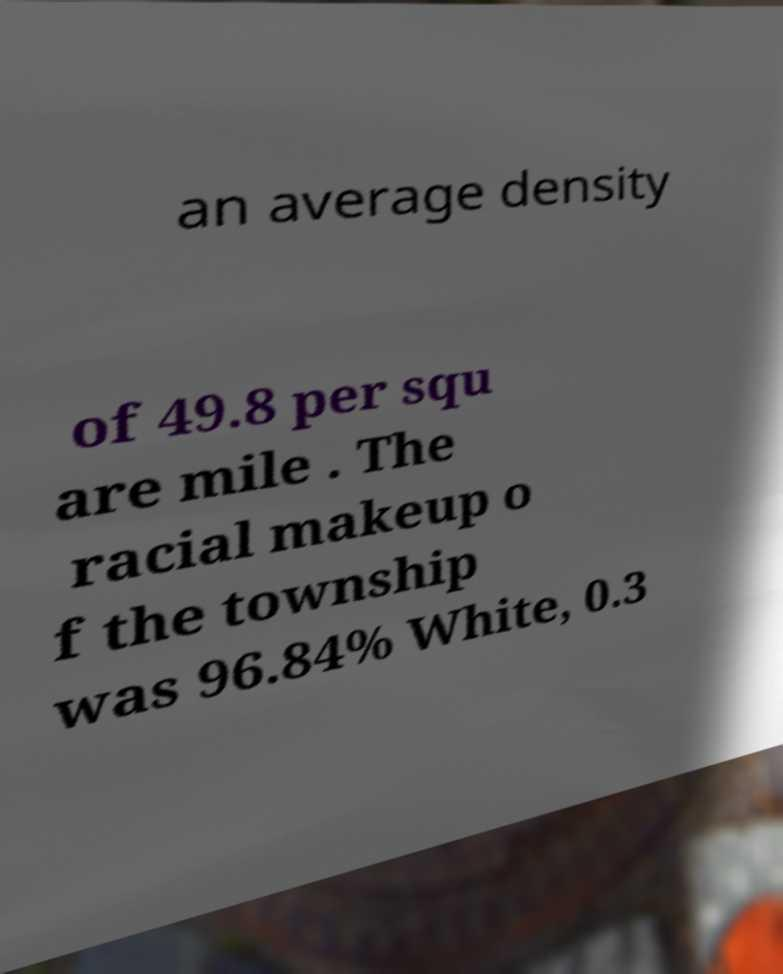Can you accurately transcribe the text from the provided image for me? an average density of 49.8 per squ are mile . The racial makeup o f the township was 96.84% White, 0.3 